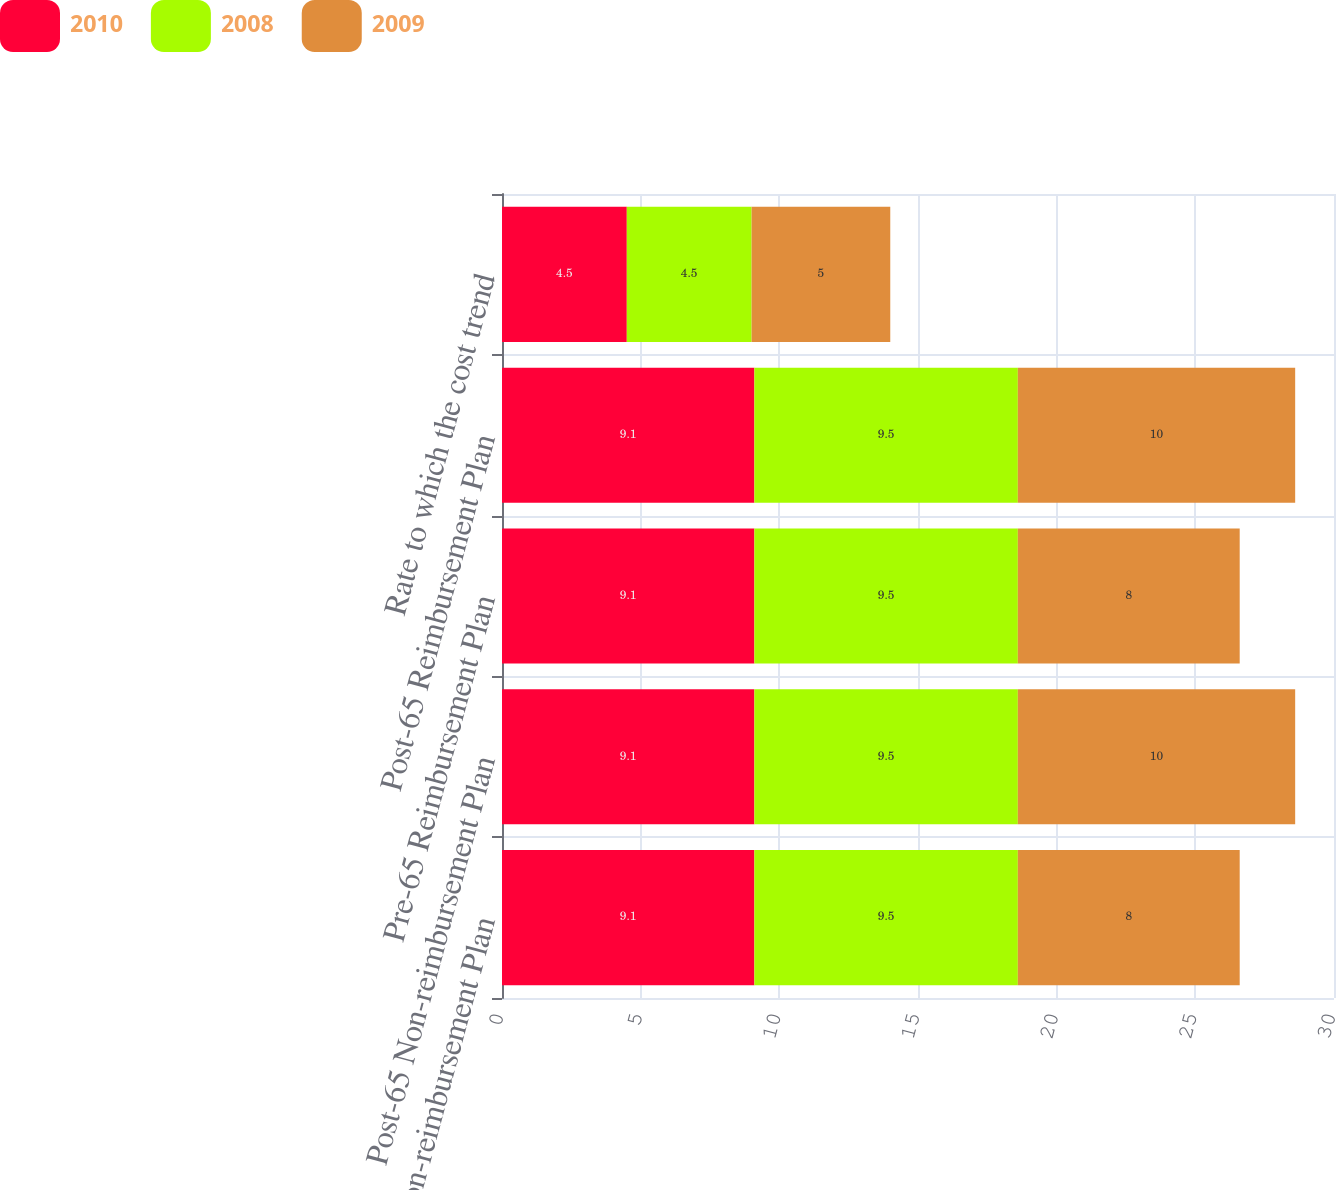Convert chart. <chart><loc_0><loc_0><loc_500><loc_500><stacked_bar_chart><ecel><fcel>Pre-65 Non-reimbursement Plan<fcel>Post-65 Non-reimbursement Plan<fcel>Pre-65 Reimbursement Plan<fcel>Post-65 Reimbursement Plan<fcel>Rate to which the cost trend<nl><fcel>2010<fcel>9.1<fcel>9.1<fcel>9.1<fcel>9.1<fcel>4.5<nl><fcel>2008<fcel>9.5<fcel>9.5<fcel>9.5<fcel>9.5<fcel>4.5<nl><fcel>2009<fcel>8<fcel>10<fcel>8<fcel>10<fcel>5<nl></chart> 